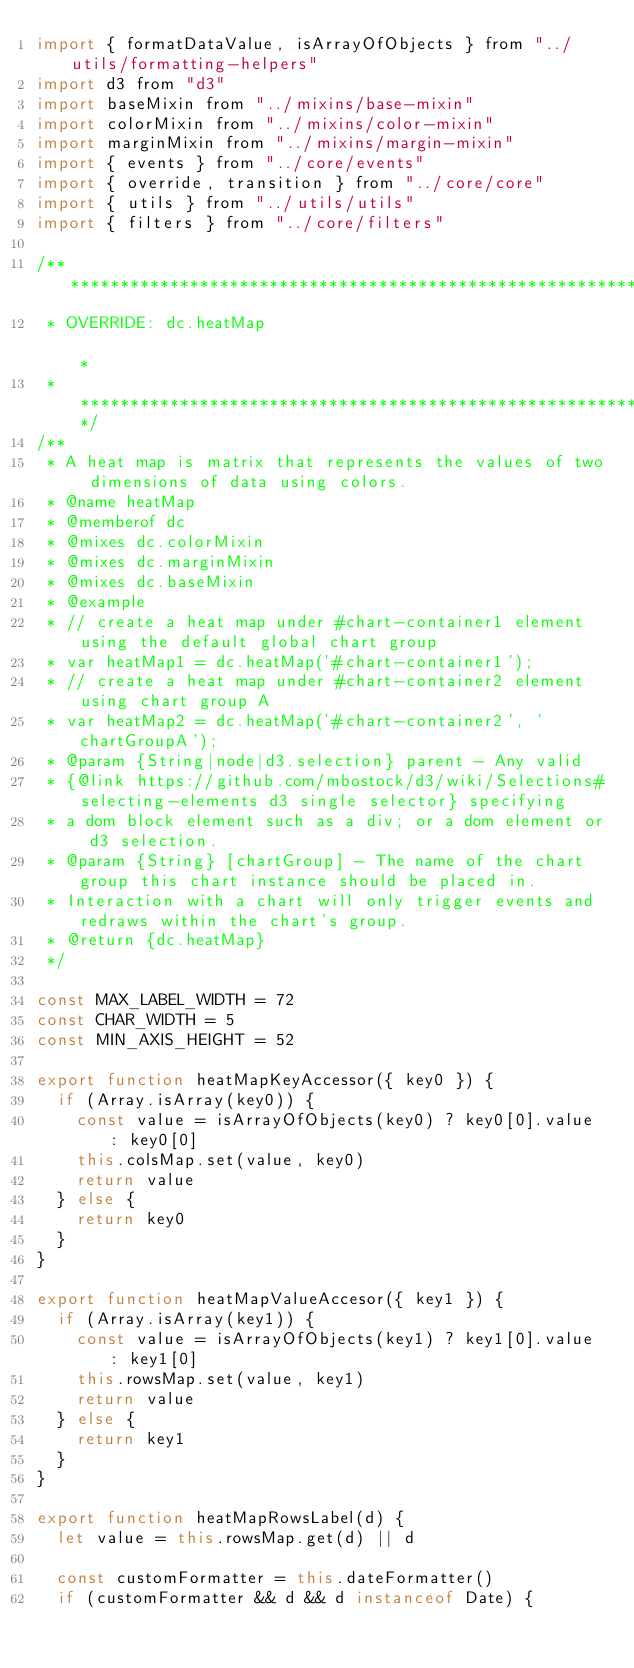Convert code to text. <code><loc_0><loc_0><loc_500><loc_500><_JavaScript_>import { formatDataValue, isArrayOfObjects } from "../utils/formatting-helpers"
import d3 from "d3"
import baseMixin from "../mixins/base-mixin"
import colorMixin from "../mixins/color-mixin"
import marginMixin from "../mixins/margin-mixin"
import { events } from "../core/events"
import { override, transition } from "../core/core"
import { utils } from "../utils/utils"
import { filters } from "../core/filters"

/** ***************************************************************************
 * OVERRIDE: dc.heatMap                                                       *
 * ***************************************************************************/
/**
 * A heat map is matrix that represents the values of two dimensions of data using colors.
 * @name heatMap
 * @memberof dc
 * @mixes dc.colorMixin
 * @mixes dc.marginMixin
 * @mixes dc.baseMixin
 * @example
 * // create a heat map under #chart-container1 element using the default global chart group
 * var heatMap1 = dc.heatMap('#chart-container1');
 * // create a heat map under #chart-container2 element using chart group A
 * var heatMap2 = dc.heatMap('#chart-container2', 'chartGroupA');
 * @param {String|node|d3.selection} parent - Any valid
 * {@link https://github.com/mbostock/d3/wiki/Selections#selecting-elements d3 single selector} specifying
 * a dom block element such as a div; or a dom element or d3 selection.
 * @param {String} [chartGroup] - The name of the chart group this chart instance should be placed in.
 * Interaction with a chart will only trigger events and redraws within the chart's group.
 * @return {dc.heatMap}
 */

const MAX_LABEL_WIDTH = 72
const CHAR_WIDTH = 5
const MIN_AXIS_HEIGHT = 52

export function heatMapKeyAccessor({ key0 }) {
  if (Array.isArray(key0)) {
    const value = isArrayOfObjects(key0) ? key0[0].value : key0[0]
    this.colsMap.set(value, key0)
    return value
  } else {
    return key0
  }
}

export function heatMapValueAccesor({ key1 }) {
  if (Array.isArray(key1)) {
    const value = isArrayOfObjects(key1) ? key1[0].value : key1[0]
    this.rowsMap.set(value, key1)
    return value
  } else {
    return key1
  }
}

export function heatMapRowsLabel(d) {
  let value = this.rowsMap.get(d) || d

  const customFormatter = this.dateFormatter()
  if (customFormatter && d && d instanceof Date) {</code> 